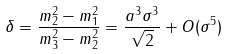Convert formula to latex. <formula><loc_0><loc_0><loc_500><loc_500>\delta = \frac { m ^ { 2 } _ { 2 } - m _ { 1 } ^ { 2 } } { m ^ { 2 } _ { 3 } - m ^ { 2 } _ { 2 } } = \frac { a ^ { 3 } \sigma ^ { 3 } } { \sqrt { 2 } } + O ( \sigma ^ { 5 } )</formula> 